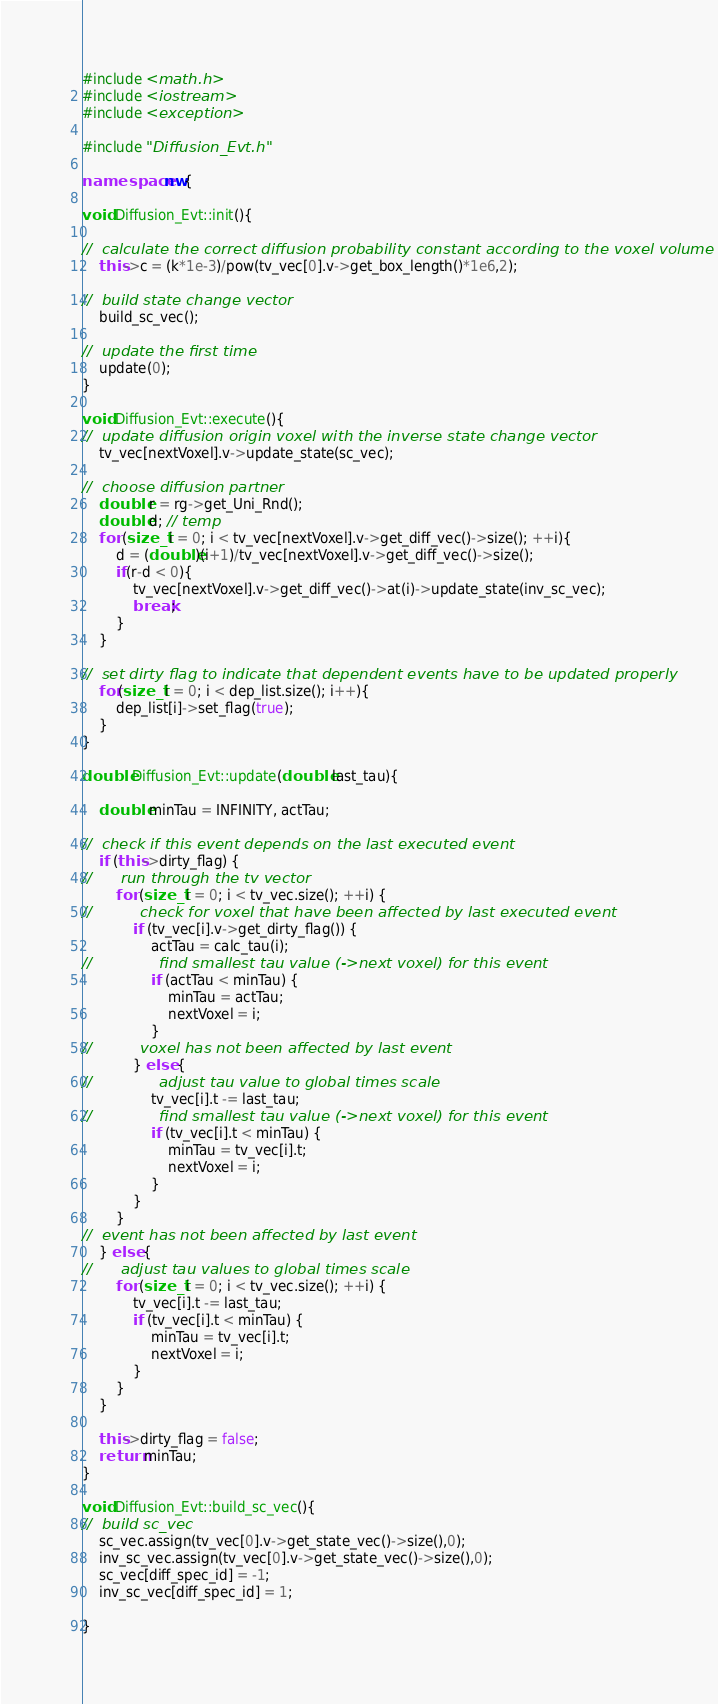Convert code to text. <code><loc_0><loc_0><loc_500><loc_500><_C++_>#include <math.h>
#include <iostream>
#include <exception>

#include "Diffusion_Evt.h"

namespace nw{

void Diffusion_Evt::init(){

//	calculate the correct diffusion probability constant according to the voxel volume
	this->c = (k*1e-3)/pow(tv_vec[0].v->get_box_length()*1e6,2);

//	build state change vector
	build_sc_vec();

//	update the first time
	update(0);
}

void Diffusion_Evt::execute(){
//	update diffusion origin voxel with the inverse state change vector
	tv_vec[nextVoxel].v->update_state(sc_vec);

//	choose diffusion partner
	double r = rg->get_Uni_Rnd();
	double d; // temp
	for (size_t i = 0; i < tv_vec[nextVoxel].v->get_diff_vec()->size(); ++i){
		d = (double)(i+1)/tv_vec[nextVoxel].v->get_diff_vec()->size();
		if(r-d < 0){
			tv_vec[nextVoxel].v->get_diff_vec()->at(i)->update_state(inv_sc_vec);
			break;
		}
	}

//	set dirty flag to indicate that dependent events have to be updated properly
	for(size_t i = 0; i < dep_list.size(); i++){
		dep_list[i]->set_flag(true);
	}
}

double Diffusion_Evt::update(double last_tau){

	double minTau = INFINITY, actTau;

//	check if this event depends on the last executed event
	if (this->dirty_flag) {
//		run through the tv vector
		for (size_t i = 0; i < tv_vec.size(); ++i) {
//			check for voxel that have been affected by last executed event
			if (tv_vec[i].v->get_dirty_flag()) {
				actTau = calc_tau(i);
//				find smallest tau value (->next voxel) for this event
				if (actTau < minTau) {
					minTau = actTau;
					nextVoxel = i;
				}
//			voxel has not been affected by last event
			} else {
//				adjust tau value to global times scale
				tv_vec[i].t -= last_tau;
//				find smallest tau value (->next voxel) for this event
				if (tv_vec[i].t < minTau) {
					minTau = tv_vec[i].t;
					nextVoxel = i;
				}
			}
		}
//  event has not been affected by last event
	} else {
//		adjust tau values to global times scale
		for (size_t i = 0; i < tv_vec.size(); ++i) {
			tv_vec[i].t -= last_tau;
			if (tv_vec[i].t < minTau) {
				minTau = tv_vec[i].t;
				nextVoxel = i;
			}
		}
	}

	this->dirty_flag = false;
	return minTau;
}

void Diffusion_Evt::build_sc_vec(){
//	build sc_vec
	sc_vec.assign(tv_vec[0].v->get_state_vec()->size(),0);
	inv_sc_vec.assign(tv_vec[0].v->get_state_vec()->size(),0);
	sc_vec[diff_spec_id] = -1;
	inv_sc_vec[diff_spec_id] = 1;

}
</code> 